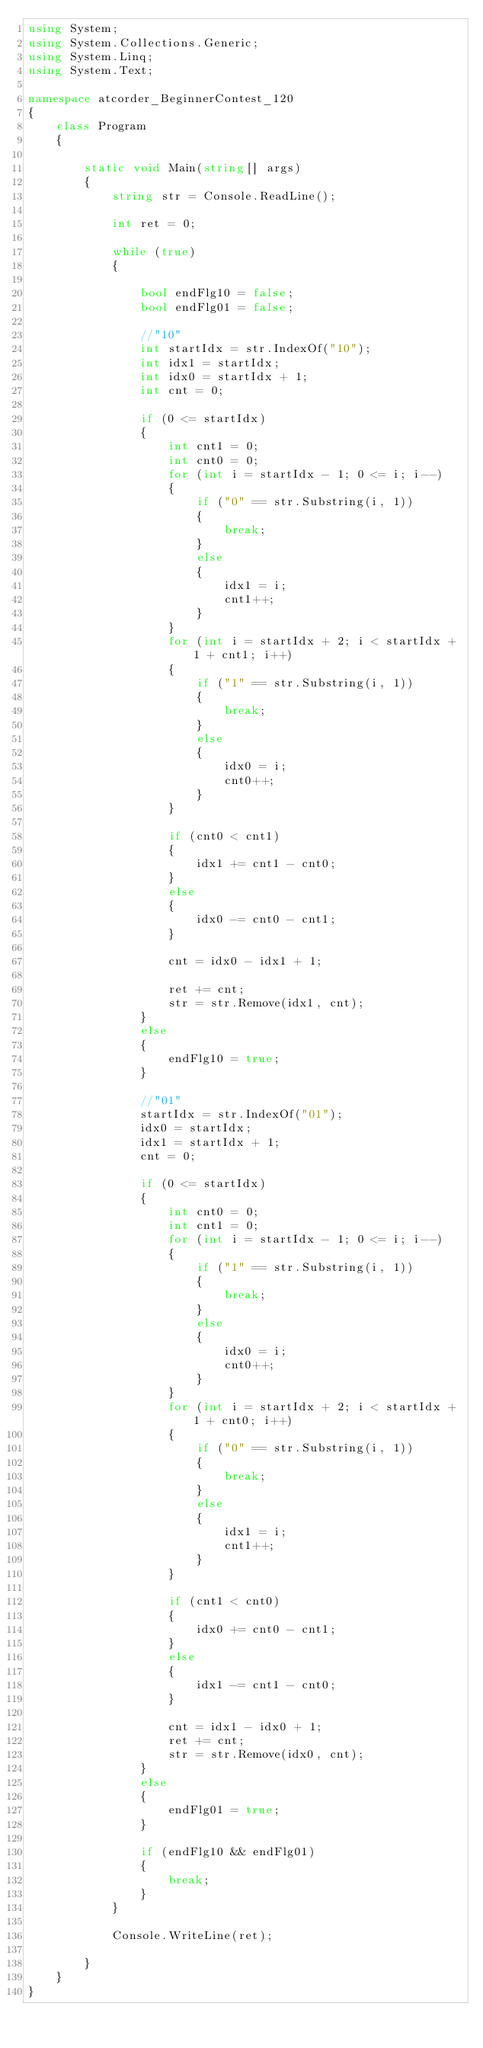<code> <loc_0><loc_0><loc_500><loc_500><_C#_>using System;
using System.Collections.Generic;
using System.Linq;
using System.Text;

namespace atcorder_BeginnerContest_120
{
    class Program
    {

        static void Main(string[] args)
        {
            string str = Console.ReadLine();

            int ret = 0;

            while (true)
            {

                bool endFlg10 = false;
                bool endFlg01 = false;

                //"10"
                int startIdx = str.IndexOf("10");
                int idx1 = startIdx;
                int idx0 = startIdx + 1;
                int cnt = 0;

                if (0 <= startIdx)
                {
                    int cnt1 = 0;
                    int cnt0 = 0;
                    for (int i = startIdx - 1; 0 <= i; i--)
                    {
                        if ("0" == str.Substring(i, 1))
                        {
                            break;
                        }
                        else
                        {
                            idx1 = i;
                            cnt1++;
                        }
                    }
                    for (int i = startIdx + 2; i < startIdx + 1 + cnt1; i++)
                    {
                        if ("1" == str.Substring(i, 1))
                        {
                            break;
                        }
                        else
                        {
                            idx0 = i;
                            cnt0++;
                        }
                    }

                    if (cnt0 < cnt1)
                    {
                        idx1 += cnt1 - cnt0; 
                    }
                    else
                    {
                        idx0 -= cnt0 - cnt1;                     
                    }

                    cnt = idx0 - idx1 + 1;

                    ret += cnt;
                    str = str.Remove(idx1, cnt);
                }
                else
                {
                    endFlg10 = true;
                }

                //"01"
                startIdx = str.IndexOf("01");
                idx0 = startIdx;
                idx1 = startIdx + 1;
                cnt = 0;

                if (0 <= startIdx)
                {
                    int cnt0 = 0;
                    int cnt1 = 0;
                    for (int i = startIdx - 1; 0 <= i; i--)
                    {
                        if ("1" == str.Substring(i, 1))
                        {
                            break;
                        }
                        else
                        {
                            idx0 = i;
                            cnt0++;
                        }
                    }
                    for (int i = startIdx + 2; i < startIdx + 1 + cnt0; i++)
                    {
                        if ("0" == str.Substring(i, 1))
                        {
                            break;
                        }
                        else
                        {
                            idx1 = i;
                            cnt1++;
                        }
                    }

                    if (cnt1 < cnt0)
                    {
                        idx0 += cnt0 - cnt1;
                    }
                    else
                    {
                        idx1 -= cnt1 - cnt0;
                    }

                    cnt = idx1 - idx0 + 1;
                    ret += cnt;
                    str = str.Remove(idx0, cnt);
                }
                else
                {
                    endFlg01 = true;
                }

                if (endFlg10 && endFlg01)
                {
                    break;
                }
            }

            Console.WriteLine(ret);

        }
    }
}
</code> 